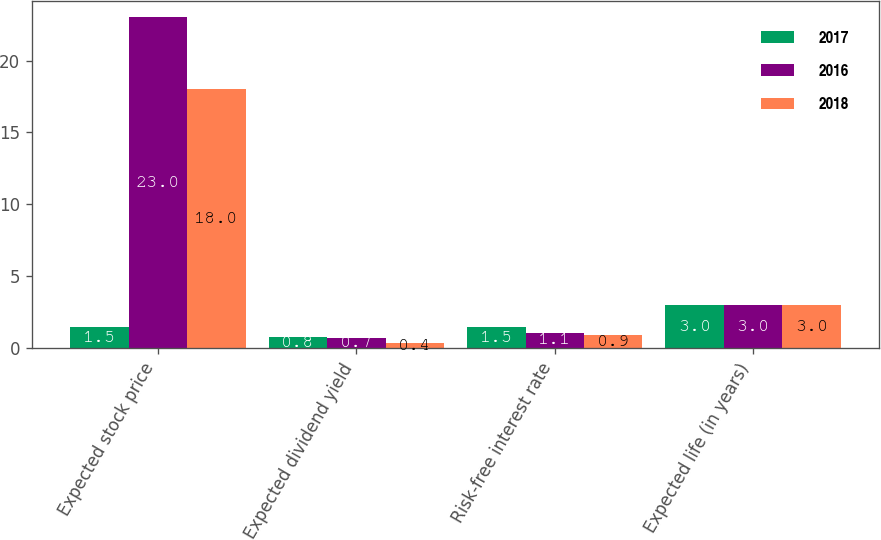<chart> <loc_0><loc_0><loc_500><loc_500><stacked_bar_chart><ecel><fcel>Expected stock price<fcel>Expected dividend yield<fcel>Risk-free interest rate<fcel>Expected life (in years)<nl><fcel>2017<fcel>1.5<fcel>0.8<fcel>1.5<fcel>3<nl><fcel>2016<fcel>23<fcel>0.7<fcel>1.1<fcel>3<nl><fcel>2018<fcel>18<fcel>0.4<fcel>0.9<fcel>3<nl></chart> 